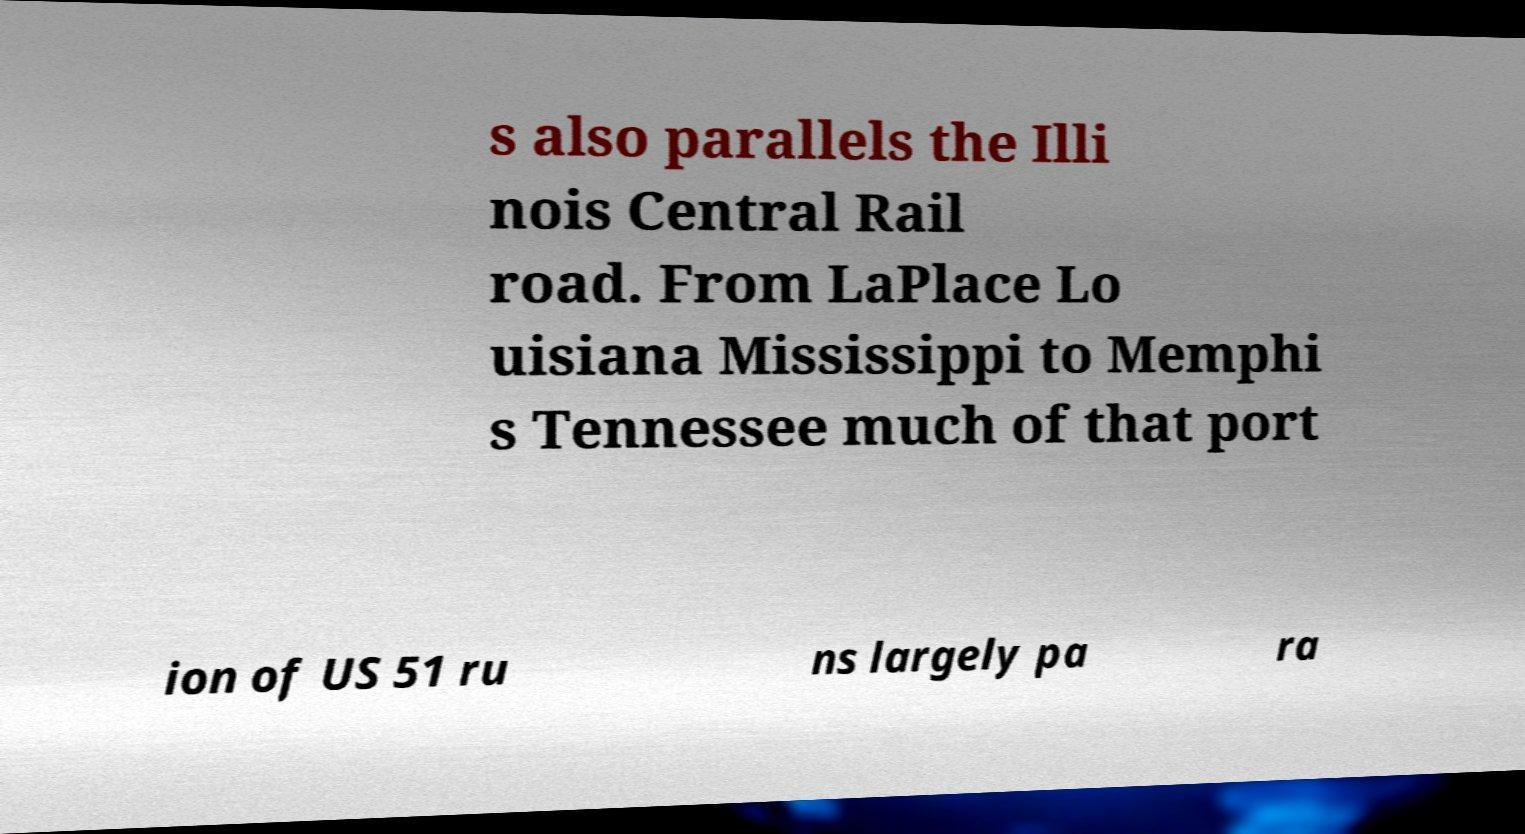Can you accurately transcribe the text from the provided image for me? s also parallels the Illi nois Central Rail road. From LaPlace Lo uisiana Mississippi to Memphi s Tennessee much of that port ion of US 51 ru ns largely pa ra 